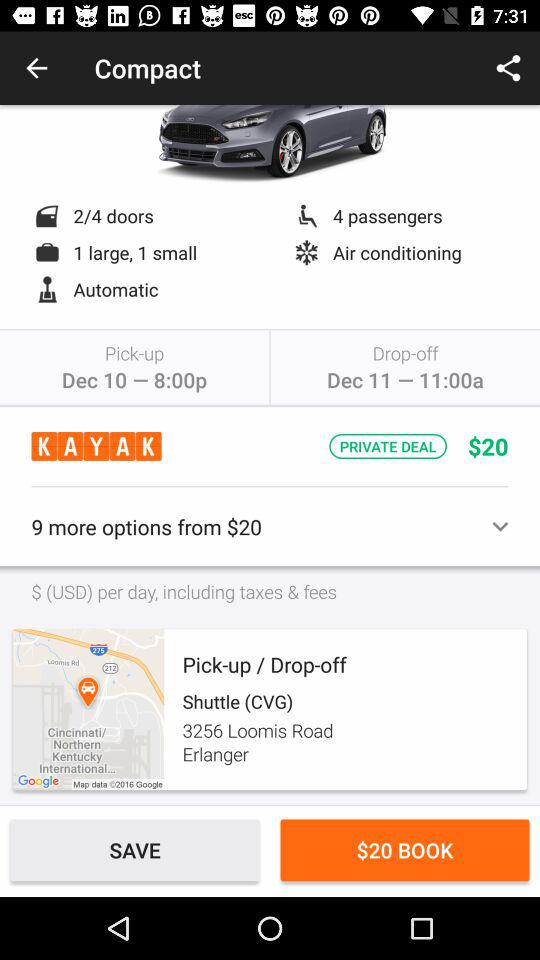What is the category of car? The category of car is "Compact". 